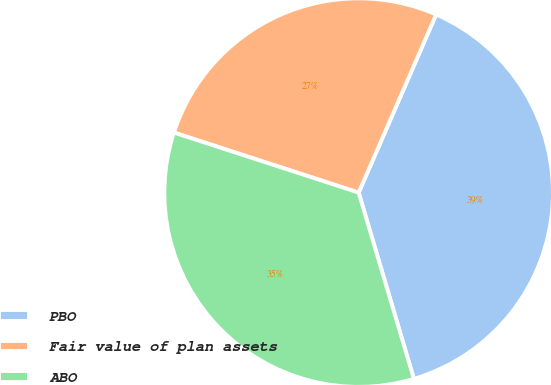Convert chart to OTSL. <chart><loc_0><loc_0><loc_500><loc_500><pie_chart><fcel>PBO<fcel>Fair value of plan assets<fcel>ABO<nl><fcel>38.88%<fcel>26.53%<fcel>34.59%<nl></chart> 